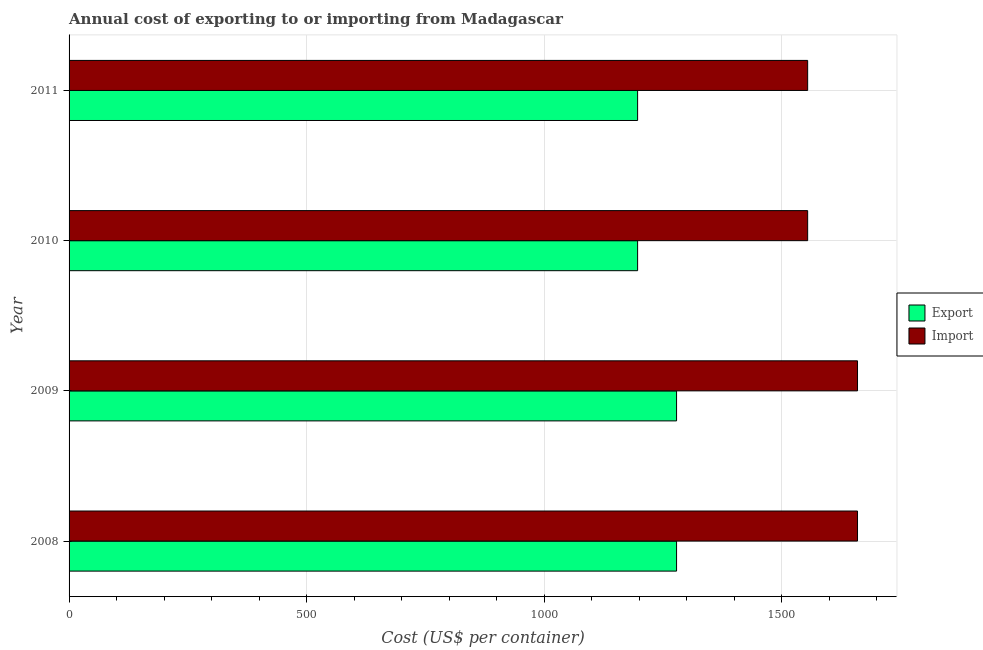How many groups of bars are there?
Offer a terse response. 4. Are the number of bars on each tick of the Y-axis equal?
Offer a very short reply. Yes. How many bars are there on the 4th tick from the top?
Your response must be concise. 2. How many bars are there on the 2nd tick from the bottom?
Provide a short and direct response. 2. In how many cases, is the number of bars for a given year not equal to the number of legend labels?
Ensure brevity in your answer.  0. What is the export cost in 2009?
Offer a very short reply. 1279. Across all years, what is the maximum import cost?
Ensure brevity in your answer.  1660. Across all years, what is the minimum export cost?
Your answer should be compact. 1197. In which year was the export cost maximum?
Make the answer very short. 2008. In which year was the import cost minimum?
Ensure brevity in your answer.  2010. What is the total export cost in the graph?
Make the answer very short. 4952. What is the difference between the import cost in 2008 and that in 2010?
Offer a terse response. 105. What is the difference between the export cost in 2008 and the import cost in 2010?
Offer a terse response. -276. What is the average import cost per year?
Your response must be concise. 1607.5. In the year 2010, what is the difference between the import cost and export cost?
Provide a short and direct response. 358. In how many years, is the export cost greater than 600 US$?
Your response must be concise. 4. What is the ratio of the export cost in 2009 to that in 2010?
Provide a short and direct response. 1.07. Is the export cost in 2010 less than that in 2011?
Offer a very short reply. No. Is the difference between the import cost in 2010 and 2011 greater than the difference between the export cost in 2010 and 2011?
Your answer should be compact. No. What is the difference between the highest and the second highest export cost?
Ensure brevity in your answer.  0. What is the difference between the highest and the lowest export cost?
Offer a terse response. 82. What does the 2nd bar from the top in 2010 represents?
Provide a short and direct response. Export. What does the 1st bar from the bottom in 2009 represents?
Provide a short and direct response. Export. How many bars are there?
Ensure brevity in your answer.  8. What is the difference between two consecutive major ticks on the X-axis?
Offer a very short reply. 500. Are the values on the major ticks of X-axis written in scientific E-notation?
Keep it short and to the point. No. Does the graph contain any zero values?
Your response must be concise. No. Where does the legend appear in the graph?
Your response must be concise. Center right. What is the title of the graph?
Offer a terse response. Annual cost of exporting to or importing from Madagascar. What is the label or title of the X-axis?
Offer a very short reply. Cost (US$ per container). What is the Cost (US$ per container) in Export in 2008?
Offer a terse response. 1279. What is the Cost (US$ per container) of Import in 2008?
Offer a terse response. 1660. What is the Cost (US$ per container) in Export in 2009?
Ensure brevity in your answer.  1279. What is the Cost (US$ per container) of Import in 2009?
Make the answer very short. 1660. What is the Cost (US$ per container) of Export in 2010?
Offer a terse response. 1197. What is the Cost (US$ per container) in Import in 2010?
Your answer should be compact. 1555. What is the Cost (US$ per container) of Export in 2011?
Provide a short and direct response. 1197. What is the Cost (US$ per container) of Import in 2011?
Provide a short and direct response. 1555. Across all years, what is the maximum Cost (US$ per container) of Export?
Your answer should be very brief. 1279. Across all years, what is the maximum Cost (US$ per container) of Import?
Provide a short and direct response. 1660. Across all years, what is the minimum Cost (US$ per container) in Export?
Offer a terse response. 1197. Across all years, what is the minimum Cost (US$ per container) of Import?
Your response must be concise. 1555. What is the total Cost (US$ per container) in Export in the graph?
Offer a very short reply. 4952. What is the total Cost (US$ per container) of Import in the graph?
Ensure brevity in your answer.  6430. What is the difference between the Cost (US$ per container) in Import in 2008 and that in 2009?
Your response must be concise. 0. What is the difference between the Cost (US$ per container) in Export in 2008 and that in 2010?
Make the answer very short. 82. What is the difference between the Cost (US$ per container) of Import in 2008 and that in 2010?
Give a very brief answer. 105. What is the difference between the Cost (US$ per container) of Import in 2008 and that in 2011?
Provide a succinct answer. 105. What is the difference between the Cost (US$ per container) in Import in 2009 and that in 2010?
Offer a very short reply. 105. What is the difference between the Cost (US$ per container) in Import in 2009 and that in 2011?
Make the answer very short. 105. What is the difference between the Cost (US$ per container) in Export in 2008 and the Cost (US$ per container) in Import in 2009?
Make the answer very short. -381. What is the difference between the Cost (US$ per container) of Export in 2008 and the Cost (US$ per container) of Import in 2010?
Offer a very short reply. -276. What is the difference between the Cost (US$ per container) of Export in 2008 and the Cost (US$ per container) of Import in 2011?
Make the answer very short. -276. What is the difference between the Cost (US$ per container) of Export in 2009 and the Cost (US$ per container) of Import in 2010?
Make the answer very short. -276. What is the difference between the Cost (US$ per container) in Export in 2009 and the Cost (US$ per container) in Import in 2011?
Give a very brief answer. -276. What is the difference between the Cost (US$ per container) in Export in 2010 and the Cost (US$ per container) in Import in 2011?
Your answer should be compact. -358. What is the average Cost (US$ per container) in Export per year?
Offer a terse response. 1238. What is the average Cost (US$ per container) of Import per year?
Your response must be concise. 1607.5. In the year 2008, what is the difference between the Cost (US$ per container) in Export and Cost (US$ per container) in Import?
Your response must be concise. -381. In the year 2009, what is the difference between the Cost (US$ per container) in Export and Cost (US$ per container) in Import?
Your answer should be compact. -381. In the year 2010, what is the difference between the Cost (US$ per container) in Export and Cost (US$ per container) in Import?
Make the answer very short. -358. In the year 2011, what is the difference between the Cost (US$ per container) of Export and Cost (US$ per container) of Import?
Keep it short and to the point. -358. What is the ratio of the Cost (US$ per container) in Export in 2008 to that in 2009?
Offer a terse response. 1. What is the ratio of the Cost (US$ per container) of Import in 2008 to that in 2009?
Ensure brevity in your answer.  1. What is the ratio of the Cost (US$ per container) of Export in 2008 to that in 2010?
Offer a terse response. 1.07. What is the ratio of the Cost (US$ per container) of Import in 2008 to that in 2010?
Give a very brief answer. 1.07. What is the ratio of the Cost (US$ per container) of Export in 2008 to that in 2011?
Provide a short and direct response. 1.07. What is the ratio of the Cost (US$ per container) in Import in 2008 to that in 2011?
Keep it short and to the point. 1.07. What is the ratio of the Cost (US$ per container) of Export in 2009 to that in 2010?
Provide a succinct answer. 1.07. What is the ratio of the Cost (US$ per container) of Import in 2009 to that in 2010?
Keep it short and to the point. 1.07. What is the ratio of the Cost (US$ per container) of Export in 2009 to that in 2011?
Your response must be concise. 1.07. What is the ratio of the Cost (US$ per container) of Import in 2009 to that in 2011?
Make the answer very short. 1.07. What is the ratio of the Cost (US$ per container) in Export in 2010 to that in 2011?
Provide a succinct answer. 1. What is the ratio of the Cost (US$ per container) of Import in 2010 to that in 2011?
Make the answer very short. 1. What is the difference between the highest and the second highest Cost (US$ per container) in Export?
Keep it short and to the point. 0. What is the difference between the highest and the second highest Cost (US$ per container) in Import?
Keep it short and to the point. 0. What is the difference between the highest and the lowest Cost (US$ per container) in Import?
Give a very brief answer. 105. 